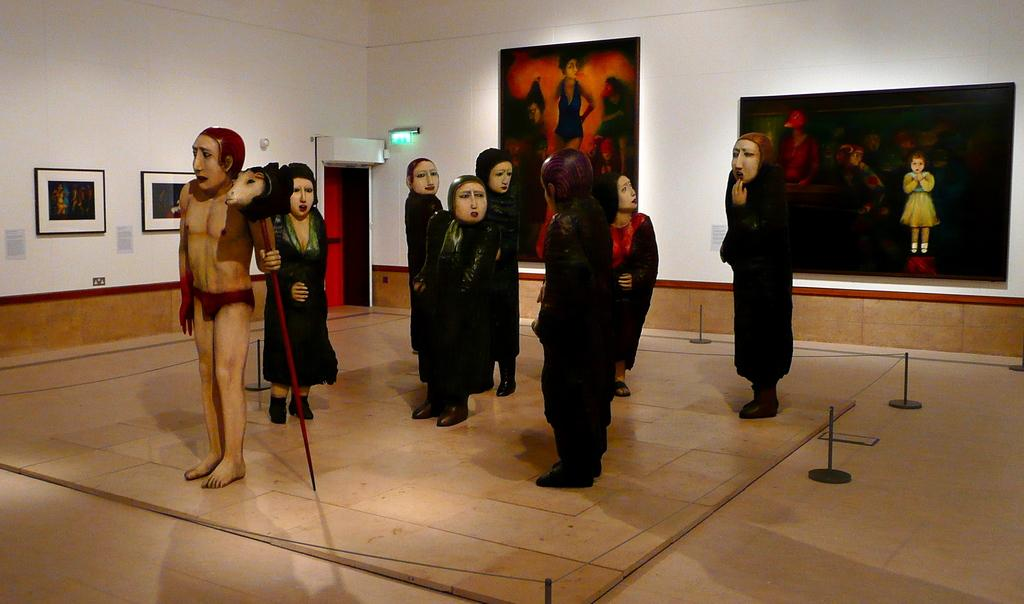What type of objects can be seen in the image? There are statues in the image. What can be found on the wall in the image? There are photos on the wall in the image. Is there any entrance or exit visible in the image? Yes, there is a door visible in the image. What type of root can be seen growing from the statues in the image? There are no roots visible in the image, as the statues are not plants or trees. 